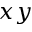<formula> <loc_0><loc_0><loc_500><loc_500>x y</formula> 